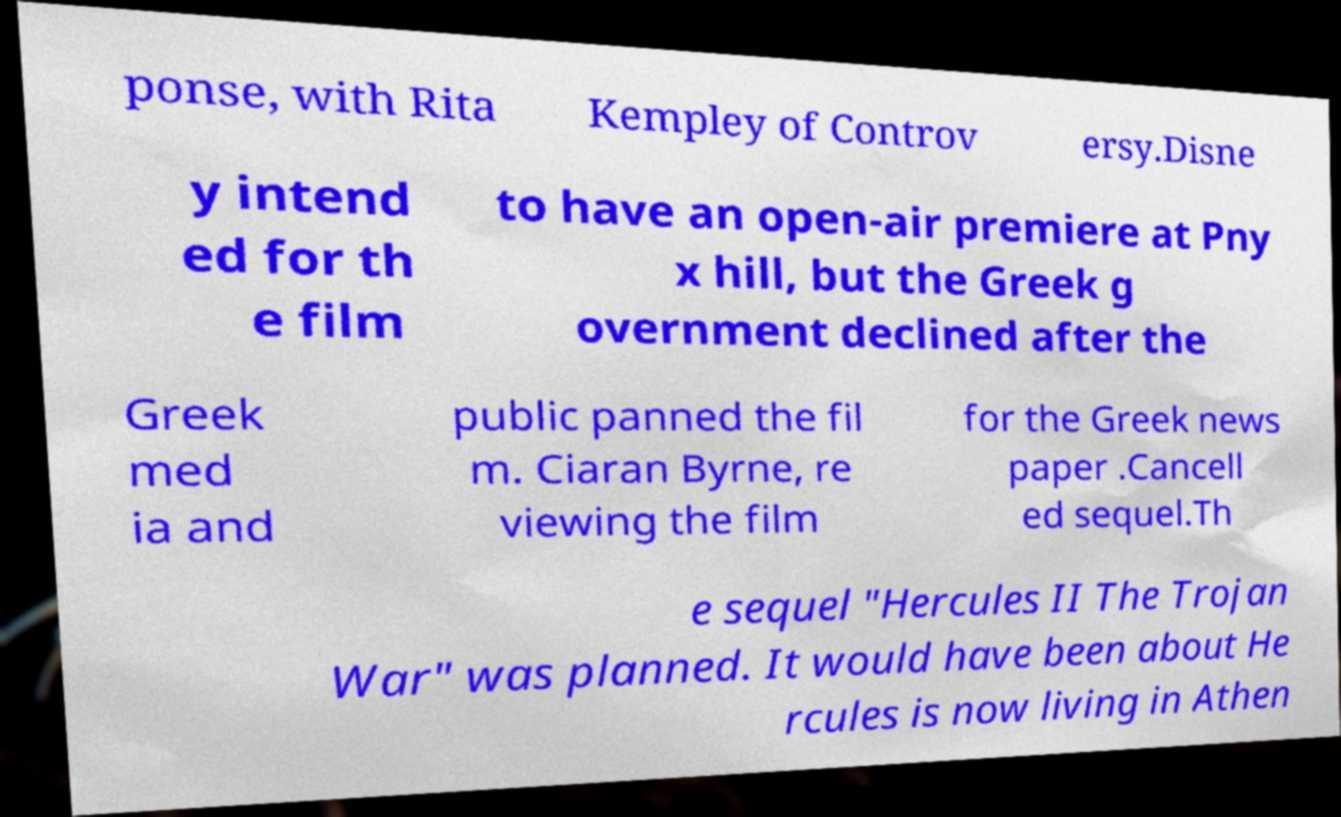What messages or text are displayed in this image? I need them in a readable, typed format. ponse, with Rita Kempley of Controv ersy.Disne y intend ed for th e film to have an open-air premiere at Pny x hill, but the Greek g overnment declined after the Greek med ia and public panned the fil m. Ciaran Byrne, re viewing the film for the Greek news paper .Cancell ed sequel.Th e sequel "Hercules II The Trojan War" was planned. It would have been about He rcules is now living in Athen 